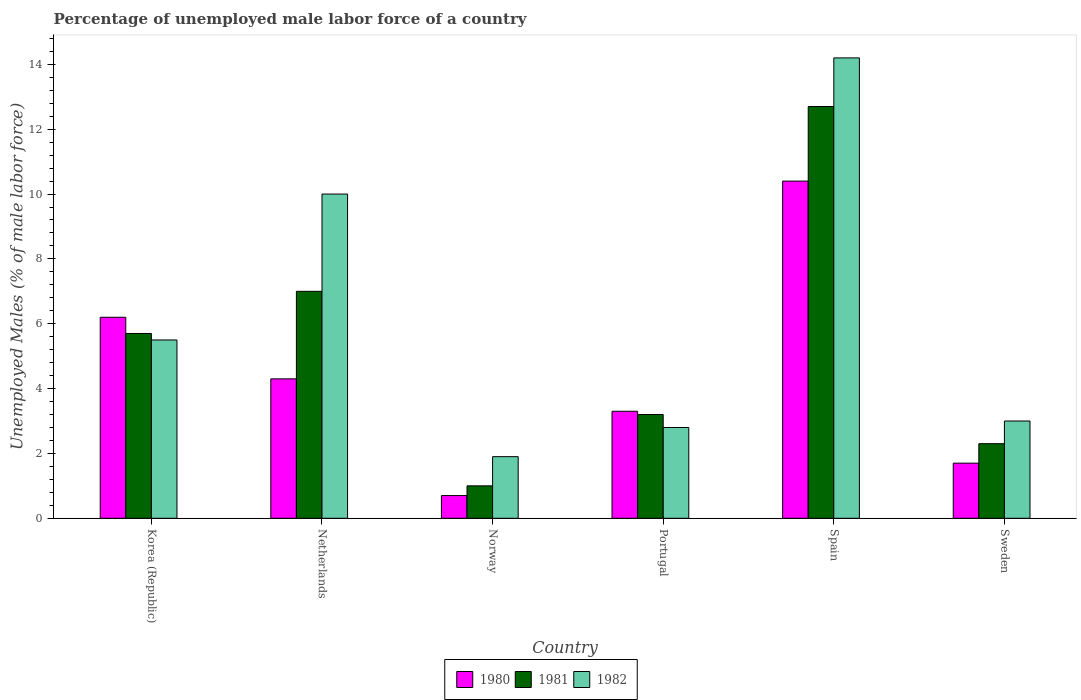Are the number of bars per tick equal to the number of legend labels?
Give a very brief answer. Yes. How many bars are there on the 2nd tick from the left?
Your answer should be very brief. 3. How many bars are there on the 5th tick from the right?
Your response must be concise. 3. What is the label of the 4th group of bars from the left?
Give a very brief answer. Portugal. What is the percentage of unemployed male labor force in 1981 in Korea (Republic)?
Your answer should be very brief. 5.7. Across all countries, what is the maximum percentage of unemployed male labor force in 1982?
Ensure brevity in your answer.  14.2. In which country was the percentage of unemployed male labor force in 1981 minimum?
Ensure brevity in your answer.  Norway. What is the total percentage of unemployed male labor force in 1981 in the graph?
Your answer should be very brief. 31.9. What is the difference between the percentage of unemployed male labor force in 1981 in Korea (Republic) and that in Netherlands?
Provide a succinct answer. -1.3. What is the difference between the percentage of unemployed male labor force in 1982 in Netherlands and the percentage of unemployed male labor force in 1980 in Spain?
Make the answer very short. -0.4. What is the average percentage of unemployed male labor force in 1982 per country?
Provide a short and direct response. 6.23. In how many countries, is the percentage of unemployed male labor force in 1981 greater than 11.2 %?
Give a very brief answer. 1. What is the ratio of the percentage of unemployed male labor force in 1981 in Korea (Republic) to that in Sweden?
Your response must be concise. 2.48. Is the percentage of unemployed male labor force in 1982 in Portugal less than that in Sweden?
Your answer should be compact. Yes. Is the difference between the percentage of unemployed male labor force in 1982 in Netherlands and Norway greater than the difference between the percentage of unemployed male labor force in 1981 in Netherlands and Norway?
Give a very brief answer. Yes. What is the difference between the highest and the second highest percentage of unemployed male labor force in 1981?
Offer a very short reply. 7. What is the difference between the highest and the lowest percentage of unemployed male labor force in 1981?
Give a very brief answer. 11.7. Is the sum of the percentage of unemployed male labor force in 1980 in Norway and Sweden greater than the maximum percentage of unemployed male labor force in 1982 across all countries?
Offer a terse response. No. What does the 1st bar from the left in Spain represents?
Provide a succinct answer. 1980. What is the difference between two consecutive major ticks on the Y-axis?
Keep it short and to the point. 2. Are the values on the major ticks of Y-axis written in scientific E-notation?
Give a very brief answer. No. Does the graph contain any zero values?
Offer a terse response. No. How many legend labels are there?
Ensure brevity in your answer.  3. What is the title of the graph?
Your answer should be compact. Percentage of unemployed male labor force of a country. What is the label or title of the X-axis?
Offer a very short reply. Country. What is the label or title of the Y-axis?
Provide a short and direct response. Unemployed Males (% of male labor force). What is the Unemployed Males (% of male labor force) in 1980 in Korea (Republic)?
Your answer should be very brief. 6.2. What is the Unemployed Males (% of male labor force) in 1981 in Korea (Republic)?
Offer a very short reply. 5.7. What is the Unemployed Males (% of male labor force) in 1980 in Netherlands?
Offer a very short reply. 4.3. What is the Unemployed Males (% of male labor force) in 1982 in Netherlands?
Ensure brevity in your answer.  10. What is the Unemployed Males (% of male labor force) in 1980 in Norway?
Give a very brief answer. 0.7. What is the Unemployed Males (% of male labor force) in 1982 in Norway?
Your answer should be compact. 1.9. What is the Unemployed Males (% of male labor force) of 1980 in Portugal?
Your answer should be very brief. 3.3. What is the Unemployed Males (% of male labor force) in 1981 in Portugal?
Ensure brevity in your answer.  3.2. What is the Unemployed Males (% of male labor force) of 1982 in Portugal?
Provide a succinct answer. 2.8. What is the Unemployed Males (% of male labor force) in 1980 in Spain?
Your answer should be compact. 10.4. What is the Unemployed Males (% of male labor force) of 1981 in Spain?
Ensure brevity in your answer.  12.7. What is the Unemployed Males (% of male labor force) in 1982 in Spain?
Your response must be concise. 14.2. What is the Unemployed Males (% of male labor force) in 1980 in Sweden?
Your answer should be very brief. 1.7. What is the Unemployed Males (% of male labor force) in 1981 in Sweden?
Provide a short and direct response. 2.3. Across all countries, what is the maximum Unemployed Males (% of male labor force) of 1980?
Offer a very short reply. 10.4. Across all countries, what is the maximum Unemployed Males (% of male labor force) of 1981?
Your answer should be very brief. 12.7. Across all countries, what is the maximum Unemployed Males (% of male labor force) of 1982?
Your answer should be very brief. 14.2. Across all countries, what is the minimum Unemployed Males (% of male labor force) of 1980?
Your answer should be very brief. 0.7. Across all countries, what is the minimum Unemployed Males (% of male labor force) in 1981?
Give a very brief answer. 1. Across all countries, what is the minimum Unemployed Males (% of male labor force) of 1982?
Make the answer very short. 1.9. What is the total Unemployed Males (% of male labor force) in 1980 in the graph?
Offer a terse response. 26.6. What is the total Unemployed Males (% of male labor force) of 1981 in the graph?
Your answer should be very brief. 31.9. What is the total Unemployed Males (% of male labor force) in 1982 in the graph?
Give a very brief answer. 37.4. What is the difference between the Unemployed Males (% of male labor force) in 1981 in Korea (Republic) and that in Netherlands?
Keep it short and to the point. -1.3. What is the difference between the Unemployed Males (% of male labor force) of 1982 in Korea (Republic) and that in Netherlands?
Make the answer very short. -4.5. What is the difference between the Unemployed Males (% of male labor force) in 1980 in Korea (Republic) and that in Norway?
Your answer should be compact. 5.5. What is the difference between the Unemployed Males (% of male labor force) in 1981 in Korea (Republic) and that in Norway?
Give a very brief answer. 4.7. What is the difference between the Unemployed Males (% of male labor force) of 1982 in Korea (Republic) and that in Norway?
Your answer should be compact. 3.6. What is the difference between the Unemployed Males (% of male labor force) of 1982 in Korea (Republic) and that in Portugal?
Offer a terse response. 2.7. What is the difference between the Unemployed Males (% of male labor force) of 1980 in Korea (Republic) and that in Spain?
Your response must be concise. -4.2. What is the difference between the Unemployed Males (% of male labor force) in 1981 in Korea (Republic) and that in Spain?
Give a very brief answer. -7. What is the difference between the Unemployed Males (% of male labor force) of 1982 in Korea (Republic) and that in Spain?
Provide a succinct answer. -8.7. What is the difference between the Unemployed Males (% of male labor force) of 1980 in Korea (Republic) and that in Sweden?
Offer a very short reply. 4.5. What is the difference between the Unemployed Males (% of male labor force) in 1981 in Netherlands and that in Norway?
Offer a very short reply. 6. What is the difference between the Unemployed Males (% of male labor force) in 1980 in Netherlands and that in Portugal?
Your answer should be very brief. 1. What is the difference between the Unemployed Males (% of male labor force) of 1982 in Netherlands and that in Portugal?
Give a very brief answer. 7.2. What is the difference between the Unemployed Males (% of male labor force) in 1980 in Netherlands and that in Sweden?
Your answer should be very brief. 2.6. What is the difference between the Unemployed Males (% of male labor force) in 1981 in Netherlands and that in Sweden?
Provide a short and direct response. 4.7. What is the difference between the Unemployed Males (% of male labor force) of 1981 in Norway and that in Portugal?
Your answer should be very brief. -2.2. What is the difference between the Unemployed Males (% of male labor force) of 1980 in Norway and that in Spain?
Your response must be concise. -9.7. What is the difference between the Unemployed Males (% of male labor force) of 1981 in Norway and that in Spain?
Ensure brevity in your answer.  -11.7. What is the difference between the Unemployed Males (% of male labor force) of 1980 in Norway and that in Sweden?
Provide a succinct answer. -1. What is the difference between the Unemployed Males (% of male labor force) in 1981 in Portugal and that in Spain?
Ensure brevity in your answer.  -9.5. What is the difference between the Unemployed Males (% of male labor force) of 1980 in Portugal and that in Sweden?
Provide a short and direct response. 1.6. What is the difference between the Unemployed Males (% of male labor force) in 1982 in Portugal and that in Sweden?
Offer a terse response. -0.2. What is the difference between the Unemployed Males (% of male labor force) of 1981 in Spain and that in Sweden?
Your answer should be very brief. 10.4. What is the difference between the Unemployed Males (% of male labor force) of 1982 in Spain and that in Sweden?
Your answer should be compact. 11.2. What is the difference between the Unemployed Males (% of male labor force) of 1980 in Korea (Republic) and the Unemployed Males (% of male labor force) of 1982 in Netherlands?
Offer a terse response. -3.8. What is the difference between the Unemployed Males (% of male labor force) in 1980 in Korea (Republic) and the Unemployed Males (% of male labor force) in 1981 in Norway?
Make the answer very short. 5.2. What is the difference between the Unemployed Males (% of male labor force) in 1980 in Korea (Republic) and the Unemployed Males (% of male labor force) in 1982 in Norway?
Provide a succinct answer. 4.3. What is the difference between the Unemployed Males (% of male labor force) of 1980 in Korea (Republic) and the Unemployed Males (% of male labor force) of 1982 in Portugal?
Provide a succinct answer. 3.4. What is the difference between the Unemployed Males (% of male labor force) in 1980 in Korea (Republic) and the Unemployed Males (% of male labor force) in 1981 in Spain?
Make the answer very short. -6.5. What is the difference between the Unemployed Males (% of male labor force) in 1981 in Korea (Republic) and the Unemployed Males (% of male labor force) in 1982 in Spain?
Your answer should be very brief. -8.5. What is the difference between the Unemployed Males (% of male labor force) of 1980 in Korea (Republic) and the Unemployed Males (% of male labor force) of 1982 in Sweden?
Make the answer very short. 3.2. What is the difference between the Unemployed Males (% of male labor force) of 1980 in Netherlands and the Unemployed Males (% of male labor force) of 1981 in Norway?
Keep it short and to the point. 3.3. What is the difference between the Unemployed Males (% of male labor force) in 1980 in Netherlands and the Unemployed Males (% of male labor force) in 1982 in Norway?
Offer a terse response. 2.4. What is the difference between the Unemployed Males (% of male labor force) in 1981 in Netherlands and the Unemployed Males (% of male labor force) in 1982 in Norway?
Provide a succinct answer. 5.1. What is the difference between the Unemployed Males (% of male labor force) of 1980 in Netherlands and the Unemployed Males (% of male labor force) of 1981 in Portugal?
Keep it short and to the point. 1.1. What is the difference between the Unemployed Males (% of male labor force) of 1980 in Netherlands and the Unemployed Males (% of male labor force) of 1981 in Sweden?
Your answer should be very brief. 2. What is the difference between the Unemployed Males (% of male labor force) in 1980 in Norway and the Unemployed Males (% of male labor force) in 1982 in Spain?
Your answer should be compact. -13.5. What is the difference between the Unemployed Males (% of male labor force) of 1981 in Norway and the Unemployed Males (% of male labor force) of 1982 in Spain?
Provide a succinct answer. -13.2. What is the difference between the Unemployed Males (% of male labor force) of 1980 in Norway and the Unemployed Males (% of male labor force) of 1981 in Sweden?
Provide a succinct answer. -1.6. What is the difference between the Unemployed Males (% of male labor force) in 1980 in Norway and the Unemployed Males (% of male labor force) in 1982 in Sweden?
Provide a short and direct response. -2.3. What is the difference between the Unemployed Males (% of male labor force) of 1981 in Norway and the Unemployed Males (% of male labor force) of 1982 in Sweden?
Your answer should be very brief. -2. What is the difference between the Unemployed Males (% of male labor force) of 1980 in Portugal and the Unemployed Males (% of male labor force) of 1981 in Sweden?
Offer a terse response. 1. What is the difference between the Unemployed Males (% of male labor force) in 1980 in Portugal and the Unemployed Males (% of male labor force) in 1982 in Sweden?
Offer a terse response. 0.3. What is the difference between the Unemployed Males (% of male labor force) of 1980 in Spain and the Unemployed Males (% of male labor force) of 1981 in Sweden?
Make the answer very short. 8.1. What is the difference between the Unemployed Males (% of male labor force) in 1980 in Spain and the Unemployed Males (% of male labor force) in 1982 in Sweden?
Your answer should be compact. 7.4. What is the average Unemployed Males (% of male labor force) of 1980 per country?
Your answer should be compact. 4.43. What is the average Unemployed Males (% of male labor force) of 1981 per country?
Ensure brevity in your answer.  5.32. What is the average Unemployed Males (% of male labor force) in 1982 per country?
Your answer should be very brief. 6.23. What is the difference between the Unemployed Males (% of male labor force) of 1980 and Unemployed Males (% of male labor force) of 1982 in Korea (Republic)?
Offer a terse response. 0.7. What is the difference between the Unemployed Males (% of male labor force) of 1981 and Unemployed Males (% of male labor force) of 1982 in Korea (Republic)?
Your answer should be compact. 0.2. What is the difference between the Unemployed Males (% of male labor force) of 1981 and Unemployed Males (% of male labor force) of 1982 in Netherlands?
Offer a very short reply. -3. What is the difference between the Unemployed Males (% of male labor force) of 1980 and Unemployed Males (% of male labor force) of 1981 in Norway?
Provide a short and direct response. -0.3. What is the difference between the Unemployed Males (% of male labor force) of 1981 and Unemployed Males (% of male labor force) of 1982 in Norway?
Keep it short and to the point. -0.9. What is the difference between the Unemployed Males (% of male labor force) of 1980 and Unemployed Males (% of male labor force) of 1982 in Portugal?
Offer a terse response. 0.5. What is the difference between the Unemployed Males (% of male labor force) of 1980 and Unemployed Males (% of male labor force) of 1982 in Spain?
Keep it short and to the point. -3.8. What is the difference between the Unemployed Males (% of male labor force) of 1981 and Unemployed Males (% of male labor force) of 1982 in Spain?
Your answer should be compact. -1.5. What is the difference between the Unemployed Males (% of male labor force) in 1980 and Unemployed Males (% of male labor force) in 1981 in Sweden?
Your answer should be very brief. -0.6. What is the difference between the Unemployed Males (% of male labor force) in 1981 and Unemployed Males (% of male labor force) in 1982 in Sweden?
Offer a very short reply. -0.7. What is the ratio of the Unemployed Males (% of male labor force) in 1980 in Korea (Republic) to that in Netherlands?
Ensure brevity in your answer.  1.44. What is the ratio of the Unemployed Males (% of male labor force) in 1981 in Korea (Republic) to that in Netherlands?
Your answer should be very brief. 0.81. What is the ratio of the Unemployed Males (% of male labor force) of 1982 in Korea (Republic) to that in Netherlands?
Provide a short and direct response. 0.55. What is the ratio of the Unemployed Males (% of male labor force) in 1980 in Korea (Republic) to that in Norway?
Offer a terse response. 8.86. What is the ratio of the Unemployed Males (% of male labor force) of 1981 in Korea (Republic) to that in Norway?
Make the answer very short. 5.7. What is the ratio of the Unemployed Males (% of male labor force) of 1982 in Korea (Republic) to that in Norway?
Keep it short and to the point. 2.89. What is the ratio of the Unemployed Males (% of male labor force) of 1980 in Korea (Republic) to that in Portugal?
Offer a terse response. 1.88. What is the ratio of the Unemployed Males (% of male labor force) of 1981 in Korea (Republic) to that in Portugal?
Give a very brief answer. 1.78. What is the ratio of the Unemployed Males (% of male labor force) in 1982 in Korea (Republic) to that in Portugal?
Your answer should be very brief. 1.96. What is the ratio of the Unemployed Males (% of male labor force) of 1980 in Korea (Republic) to that in Spain?
Make the answer very short. 0.6. What is the ratio of the Unemployed Males (% of male labor force) in 1981 in Korea (Republic) to that in Spain?
Give a very brief answer. 0.45. What is the ratio of the Unemployed Males (% of male labor force) in 1982 in Korea (Republic) to that in Spain?
Ensure brevity in your answer.  0.39. What is the ratio of the Unemployed Males (% of male labor force) in 1980 in Korea (Republic) to that in Sweden?
Provide a succinct answer. 3.65. What is the ratio of the Unemployed Males (% of male labor force) in 1981 in Korea (Republic) to that in Sweden?
Make the answer very short. 2.48. What is the ratio of the Unemployed Males (% of male labor force) of 1982 in Korea (Republic) to that in Sweden?
Your response must be concise. 1.83. What is the ratio of the Unemployed Males (% of male labor force) in 1980 in Netherlands to that in Norway?
Keep it short and to the point. 6.14. What is the ratio of the Unemployed Males (% of male labor force) in 1981 in Netherlands to that in Norway?
Provide a succinct answer. 7. What is the ratio of the Unemployed Males (% of male labor force) in 1982 in Netherlands to that in Norway?
Offer a terse response. 5.26. What is the ratio of the Unemployed Males (% of male labor force) in 1980 in Netherlands to that in Portugal?
Make the answer very short. 1.3. What is the ratio of the Unemployed Males (% of male labor force) in 1981 in Netherlands to that in Portugal?
Keep it short and to the point. 2.19. What is the ratio of the Unemployed Males (% of male labor force) of 1982 in Netherlands to that in Portugal?
Ensure brevity in your answer.  3.57. What is the ratio of the Unemployed Males (% of male labor force) of 1980 in Netherlands to that in Spain?
Give a very brief answer. 0.41. What is the ratio of the Unemployed Males (% of male labor force) in 1981 in Netherlands to that in Spain?
Offer a very short reply. 0.55. What is the ratio of the Unemployed Males (% of male labor force) in 1982 in Netherlands to that in Spain?
Provide a succinct answer. 0.7. What is the ratio of the Unemployed Males (% of male labor force) of 1980 in Netherlands to that in Sweden?
Your answer should be very brief. 2.53. What is the ratio of the Unemployed Males (% of male labor force) in 1981 in Netherlands to that in Sweden?
Ensure brevity in your answer.  3.04. What is the ratio of the Unemployed Males (% of male labor force) of 1982 in Netherlands to that in Sweden?
Provide a succinct answer. 3.33. What is the ratio of the Unemployed Males (% of male labor force) in 1980 in Norway to that in Portugal?
Ensure brevity in your answer.  0.21. What is the ratio of the Unemployed Males (% of male labor force) in 1981 in Norway to that in Portugal?
Ensure brevity in your answer.  0.31. What is the ratio of the Unemployed Males (% of male labor force) of 1982 in Norway to that in Portugal?
Offer a very short reply. 0.68. What is the ratio of the Unemployed Males (% of male labor force) of 1980 in Norway to that in Spain?
Offer a terse response. 0.07. What is the ratio of the Unemployed Males (% of male labor force) of 1981 in Norway to that in Spain?
Your answer should be very brief. 0.08. What is the ratio of the Unemployed Males (% of male labor force) in 1982 in Norway to that in Spain?
Provide a succinct answer. 0.13. What is the ratio of the Unemployed Males (% of male labor force) of 1980 in Norway to that in Sweden?
Provide a succinct answer. 0.41. What is the ratio of the Unemployed Males (% of male labor force) of 1981 in Norway to that in Sweden?
Offer a terse response. 0.43. What is the ratio of the Unemployed Males (% of male labor force) of 1982 in Norway to that in Sweden?
Ensure brevity in your answer.  0.63. What is the ratio of the Unemployed Males (% of male labor force) in 1980 in Portugal to that in Spain?
Give a very brief answer. 0.32. What is the ratio of the Unemployed Males (% of male labor force) in 1981 in Portugal to that in Spain?
Your answer should be very brief. 0.25. What is the ratio of the Unemployed Males (% of male labor force) of 1982 in Portugal to that in Spain?
Keep it short and to the point. 0.2. What is the ratio of the Unemployed Males (% of male labor force) in 1980 in Portugal to that in Sweden?
Your answer should be very brief. 1.94. What is the ratio of the Unemployed Males (% of male labor force) in 1981 in Portugal to that in Sweden?
Offer a terse response. 1.39. What is the ratio of the Unemployed Males (% of male labor force) in 1982 in Portugal to that in Sweden?
Ensure brevity in your answer.  0.93. What is the ratio of the Unemployed Males (% of male labor force) in 1980 in Spain to that in Sweden?
Your answer should be compact. 6.12. What is the ratio of the Unemployed Males (% of male labor force) in 1981 in Spain to that in Sweden?
Provide a succinct answer. 5.52. What is the ratio of the Unemployed Males (% of male labor force) of 1982 in Spain to that in Sweden?
Your answer should be very brief. 4.73. What is the difference between the highest and the second highest Unemployed Males (% of male labor force) in 1981?
Offer a terse response. 5.7. What is the difference between the highest and the lowest Unemployed Males (% of male labor force) in 1982?
Offer a terse response. 12.3. 